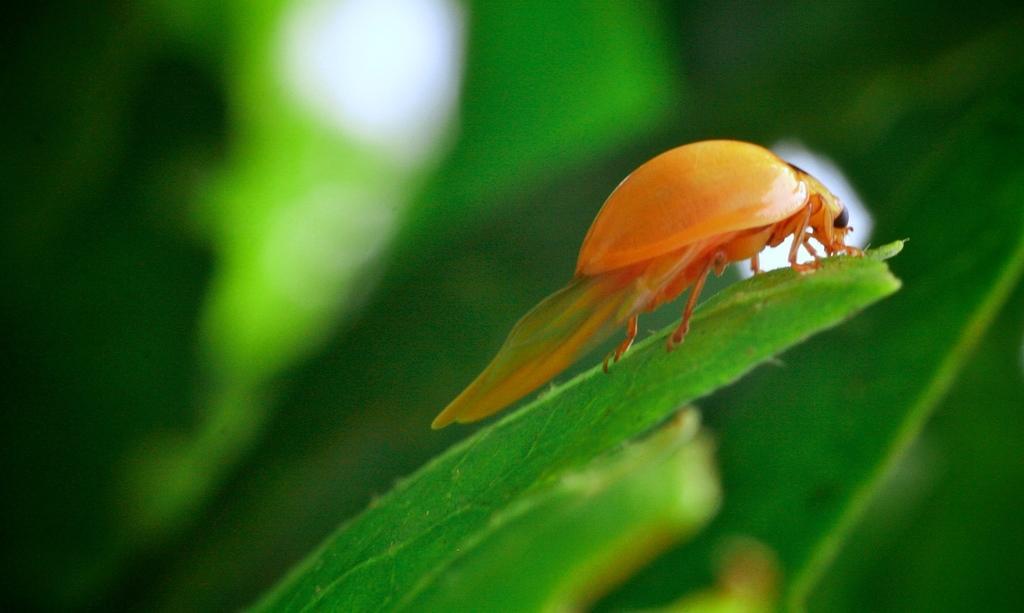Describe this image in one or two sentences. In this picture we can see an insect on a leaf and in the background it is blurry. 